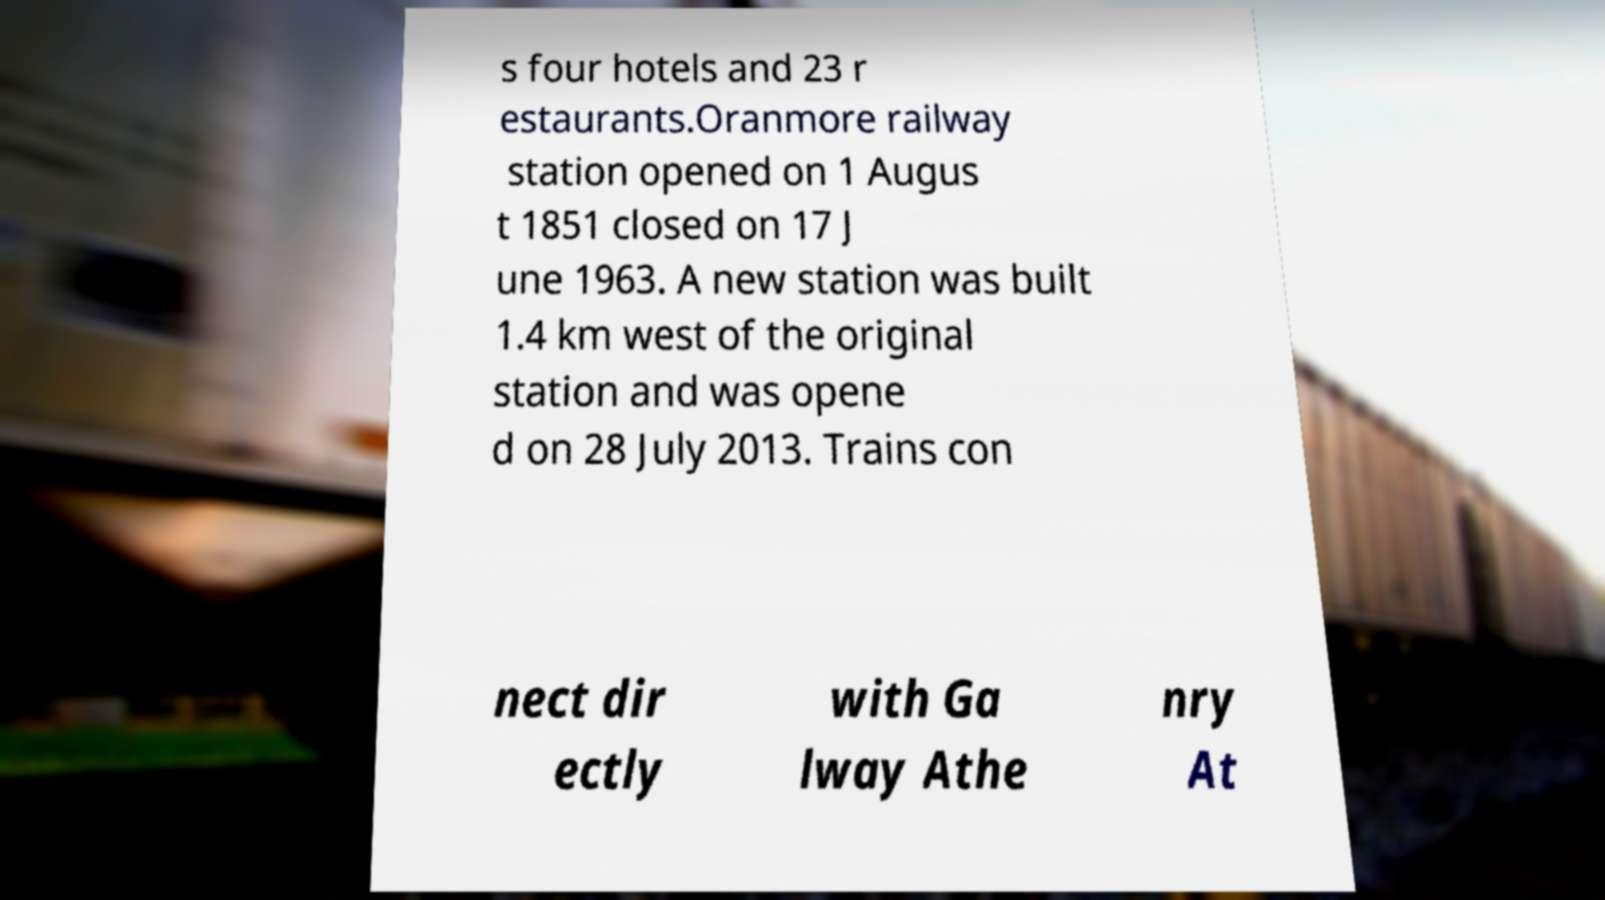For documentation purposes, I need the text within this image transcribed. Could you provide that? s four hotels and 23 r estaurants.Oranmore railway station opened on 1 Augus t 1851 closed on 17 J une 1963. A new station was built 1.4 km west of the original station and was opene d on 28 July 2013. Trains con nect dir ectly with Ga lway Athe nry At 